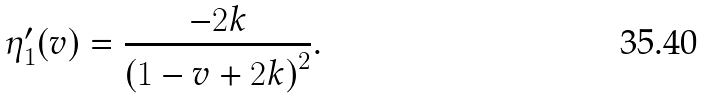<formula> <loc_0><loc_0><loc_500><loc_500>\eta _ { 1 } ^ { \prime } ( v ) = \frac { - 2 k } { \left ( 1 - v + 2 k \right ) ^ { 2 } } .</formula> 